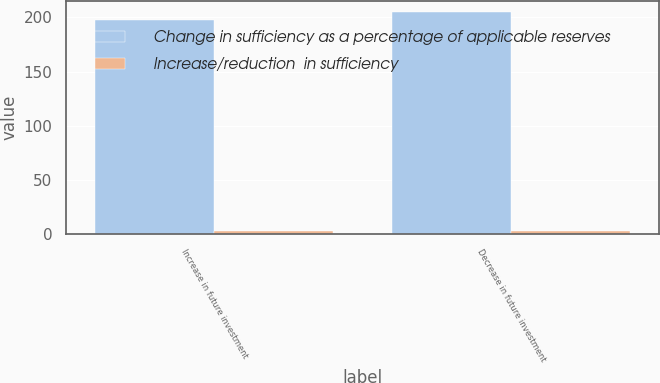Convert chart to OTSL. <chart><loc_0><loc_0><loc_500><loc_500><stacked_bar_chart><ecel><fcel>Increase in future investment<fcel>Decrease in future investment<nl><fcel>Change in sufficiency as a percentage of applicable reserves<fcel>198<fcel>205<nl><fcel>Increase/reduction  in sufficiency<fcel>3<fcel>3<nl></chart> 